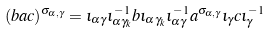Convert formula to latex. <formula><loc_0><loc_0><loc_500><loc_500>( b a c ) ^ { \sigma _ { \alpha , \gamma } } = \iota _ { \alpha \gamma } \iota _ { \alpha \gamma _ { k } } ^ { - 1 } b \iota _ { \alpha \gamma _ { k } } \iota _ { \alpha \gamma } ^ { - 1 } a ^ { \sigma _ { \alpha , \gamma } } \iota _ { \gamma } c \iota _ { \gamma } ^ { - 1 }</formula> 